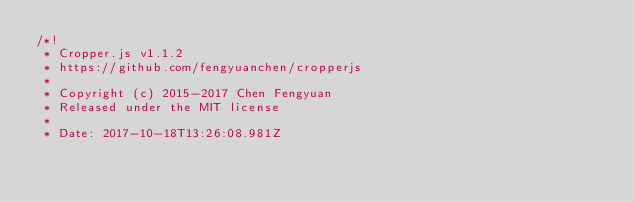Convert code to text. <code><loc_0><loc_0><loc_500><loc_500><_CSS_>/*!
 * Cropper.js v1.1.2
 * https://github.com/fengyuanchen/cropperjs
 *
 * Copyright (c) 2015-2017 Chen Fengyuan
 * Released under the MIT license
 *
 * Date: 2017-10-18T13:26:08.981Z</code> 